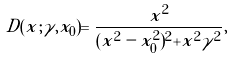Convert formula to latex. <formula><loc_0><loc_0><loc_500><loc_500>D ( x ; \gamma , x _ { 0 } ) = \frac { x ^ { 2 } } { ( x ^ { 2 } - x _ { 0 } ^ { 2 } ) ^ { 2 } + x ^ { 2 } \gamma ^ { 2 } } ,</formula> 